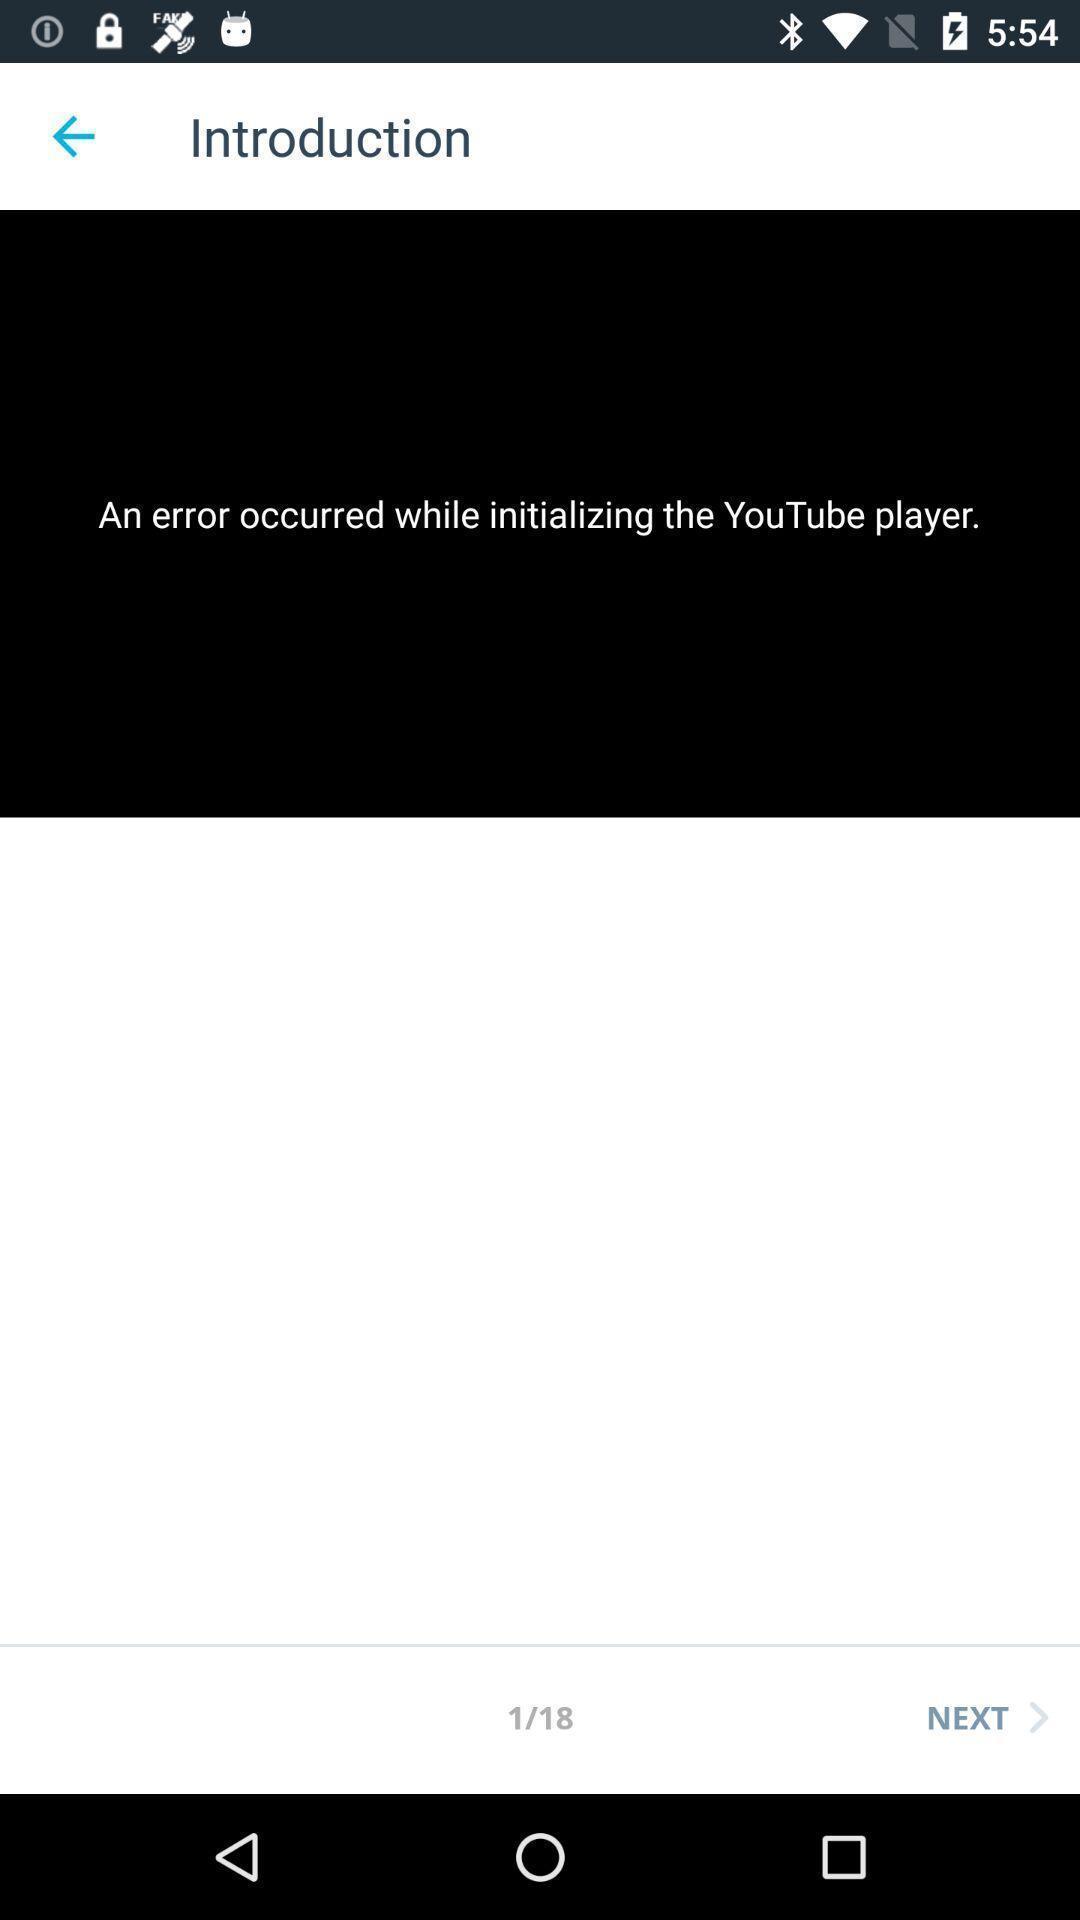Please provide a description for this image. Screen showing an error occurred while initializing a application. 